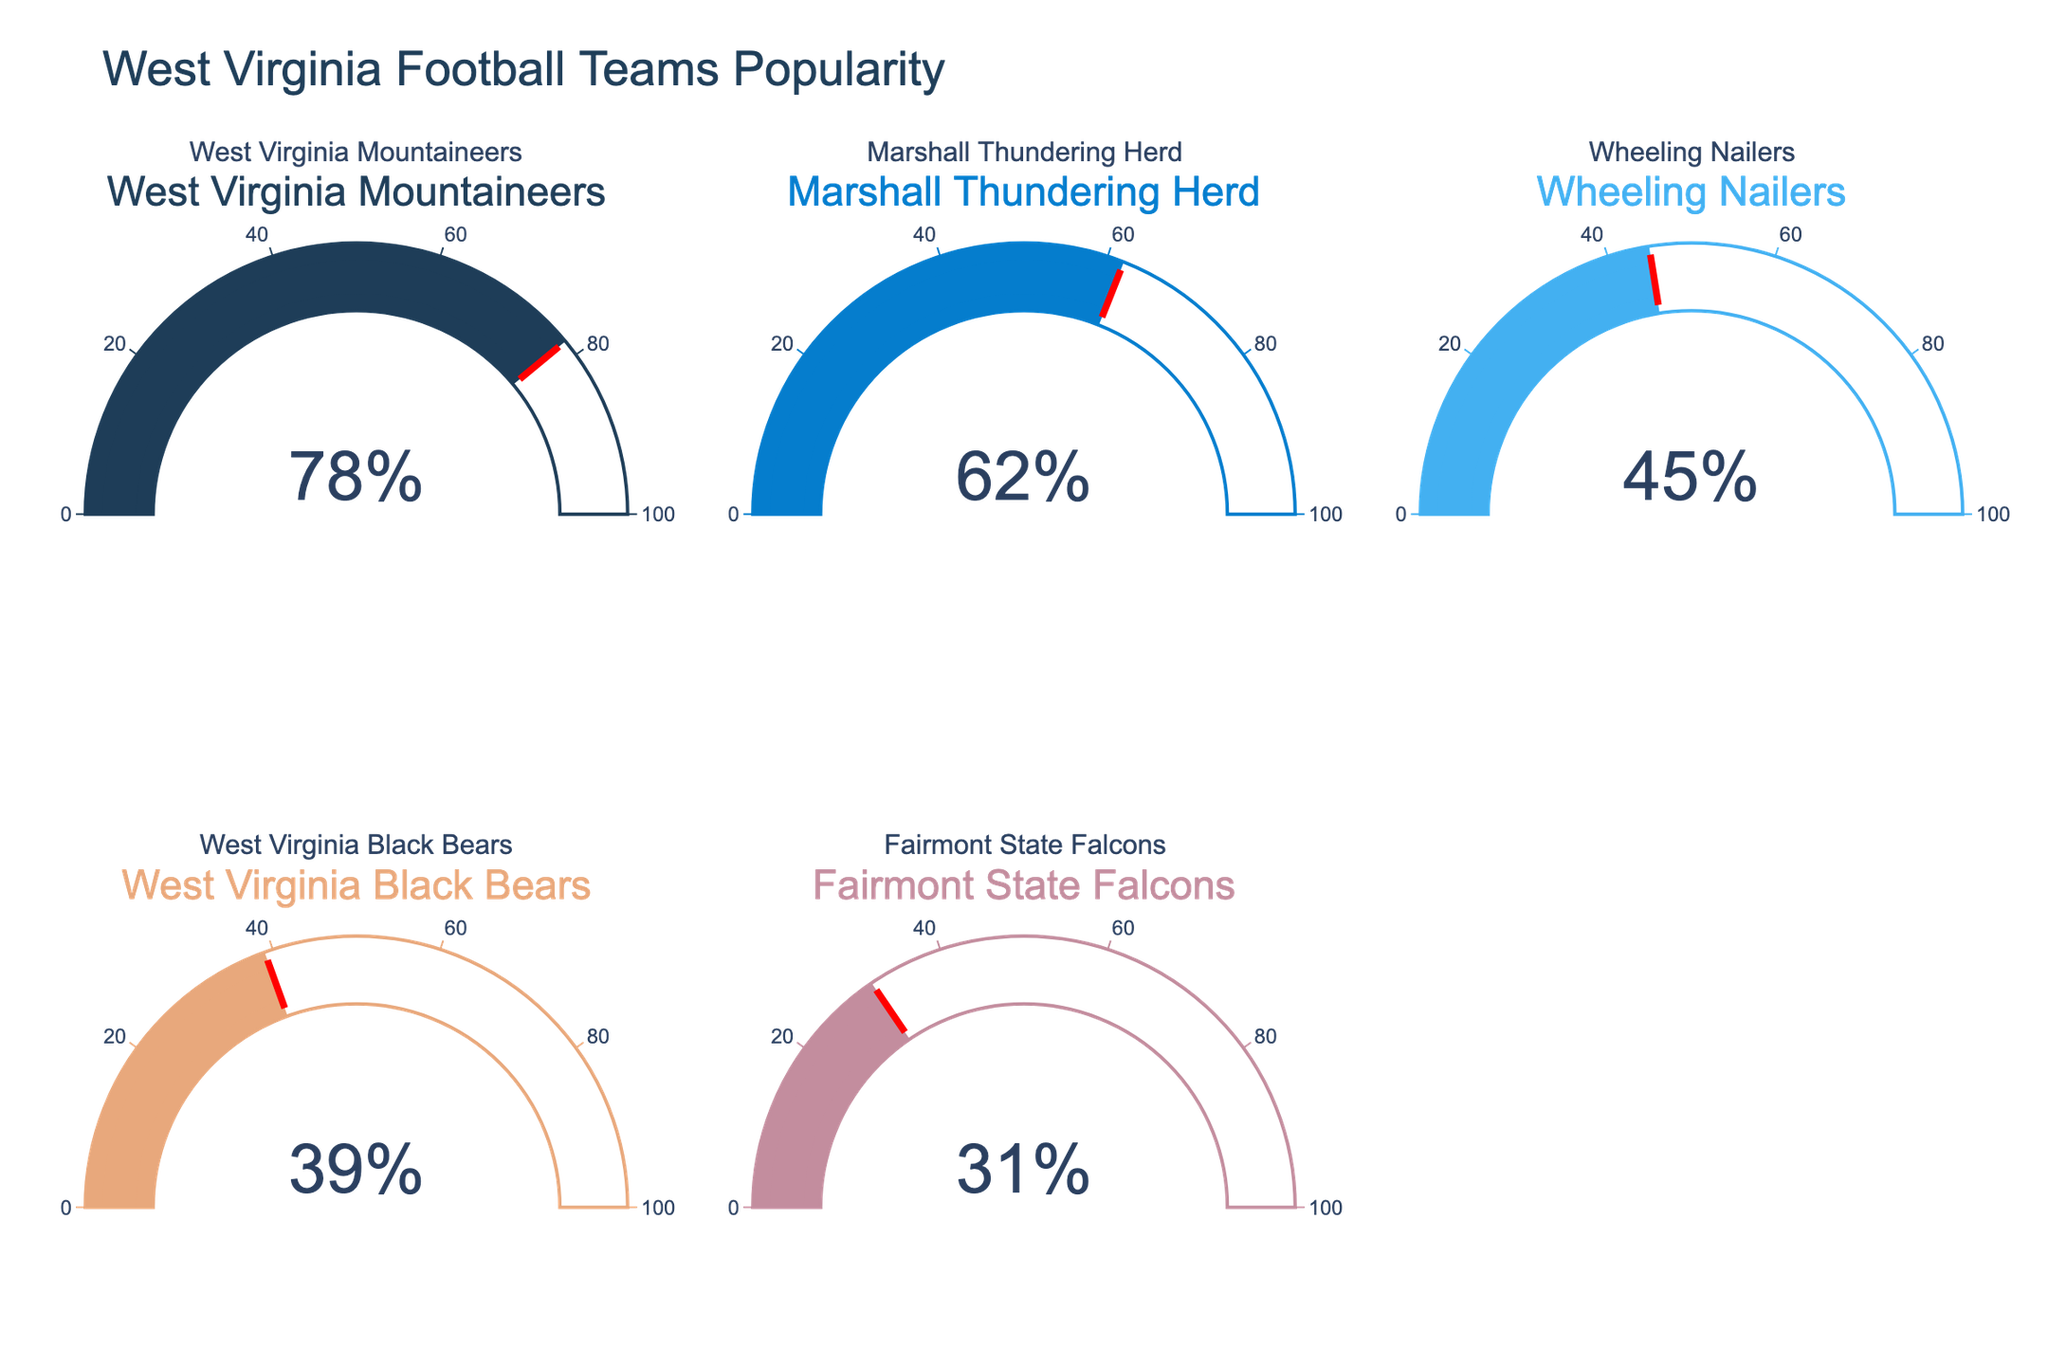What's the title of the figure? The title of the figure is prominently displayed at the top.
Answer: West Virginia Football Teams Popularity How many teams are represented in the gauge chart? By counting the number of gauges in the figure, there are five different teams represented.
Answer: Five Which team has the highest percentage of followers? Observe the gauge with the highest percentage value.
Answer: West Virginia Mountaineers Which team has a 45% following? Identify the gauge that indicates the value of 45%.
Answer: Wheeling Nailers What is the combined percentage of followers for Marshall Thundering Herd and Fairmont State Falcons? Add the percentages for Marshall Thundering Herd (62%) and Fairmont State Falcons (31%). 62 + 31 = 93
Answer: 93 What is the average percentage of followers for all teams? Calculate the sum of all percentages and divide by the total number of teams: (78 + 62 + 45 + 39 + 31)/5 = 51
Answer: 51 Which team has fewer followers, Wheeling Nailers or West Virginia Black Bears? Compare the percentage values of Wheeling Nailers (45%) and West Virginia Black Bears (39%).
Answer: West Virginia Black Bears Is the percentage of followers for Wheeling Nailers greater than that of Fairmont State Falcons? Compare the percentage of Wheeling Nailers (45%) to Fairmont State Falcons (31%).
Answer: Yes What percentage value does the team with the second-highest following have? Identify the second-highest value among all gauges.
Answer: 62% What is the difference in popularity between West Virginia Mountaineers and West Virginia Black Bears? Subtract the percentage of West Virginia Black Bears (39%) from the percentage of West Virginia Mountaineers (78%). 78 - 39 = 39
Answer: 39 